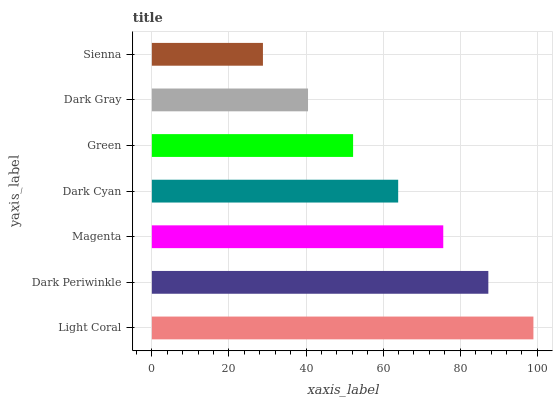Is Sienna the minimum?
Answer yes or no. Yes. Is Light Coral the maximum?
Answer yes or no. Yes. Is Dark Periwinkle the minimum?
Answer yes or no. No. Is Dark Periwinkle the maximum?
Answer yes or no. No. Is Light Coral greater than Dark Periwinkle?
Answer yes or no. Yes. Is Dark Periwinkle less than Light Coral?
Answer yes or no. Yes. Is Dark Periwinkle greater than Light Coral?
Answer yes or no. No. Is Light Coral less than Dark Periwinkle?
Answer yes or no. No. Is Dark Cyan the high median?
Answer yes or no. Yes. Is Dark Cyan the low median?
Answer yes or no. Yes. Is Dark Gray the high median?
Answer yes or no. No. Is Green the low median?
Answer yes or no. No. 